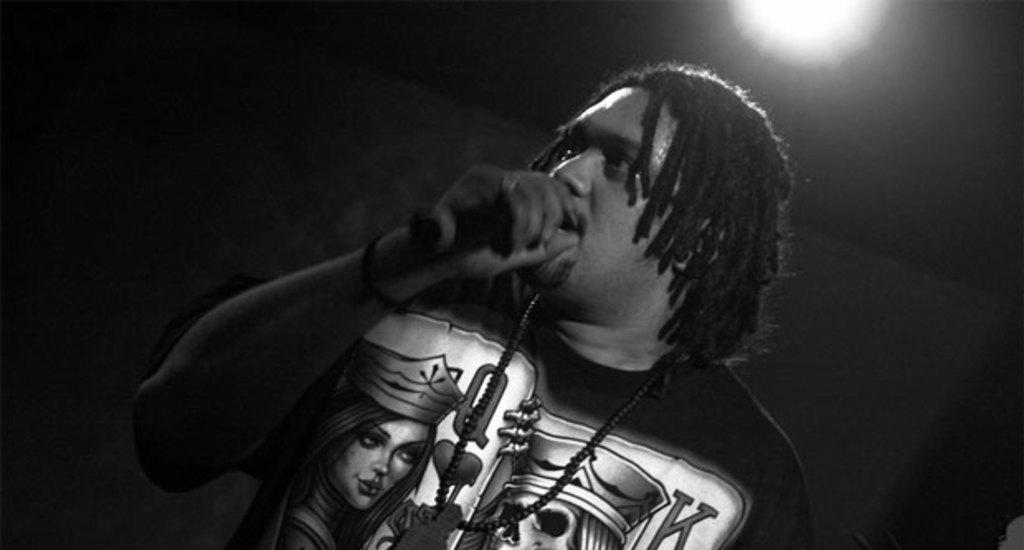What is the person in the image doing? The person is standing and holding a mic. What can be inferred about the person's possible activity or role in the image? The person might be a performer or speaker, given that they are holding a mic. What is the color or lighting condition of the background in the image? The background of the image is dark. What type of eggnog is being served in the image? There is no eggnog present in the image. Is there a bomb visible in the image? No, there is no bomb present in the image. 